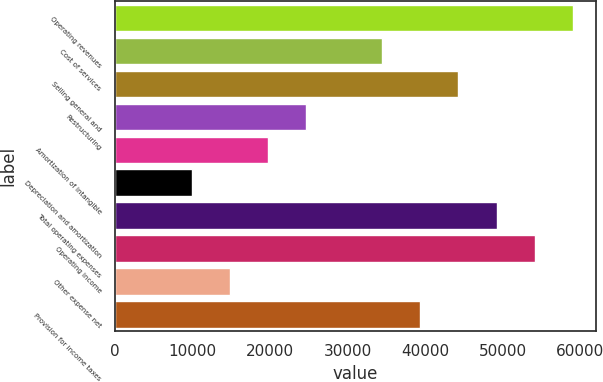<chart> <loc_0><loc_0><loc_500><loc_500><bar_chart><fcel>Operating revenues<fcel>Cost of services<fcel>Selling general and<fcel>Restructuring<fcel>Amortization of intangible<fcel>Depreciation and amortization<fcel>Total operating expenses<fcel>Operating income<fcel>Other expense net<fcel>Provision for income taxes<nl><fcel>59039.9<fcel>34440<fcel>44280<fcel>24600<fcel>19680<fcel>9840.05<fcel>49200<fcel>54120<fcel>14760<fcel>39360<nl></chart> 